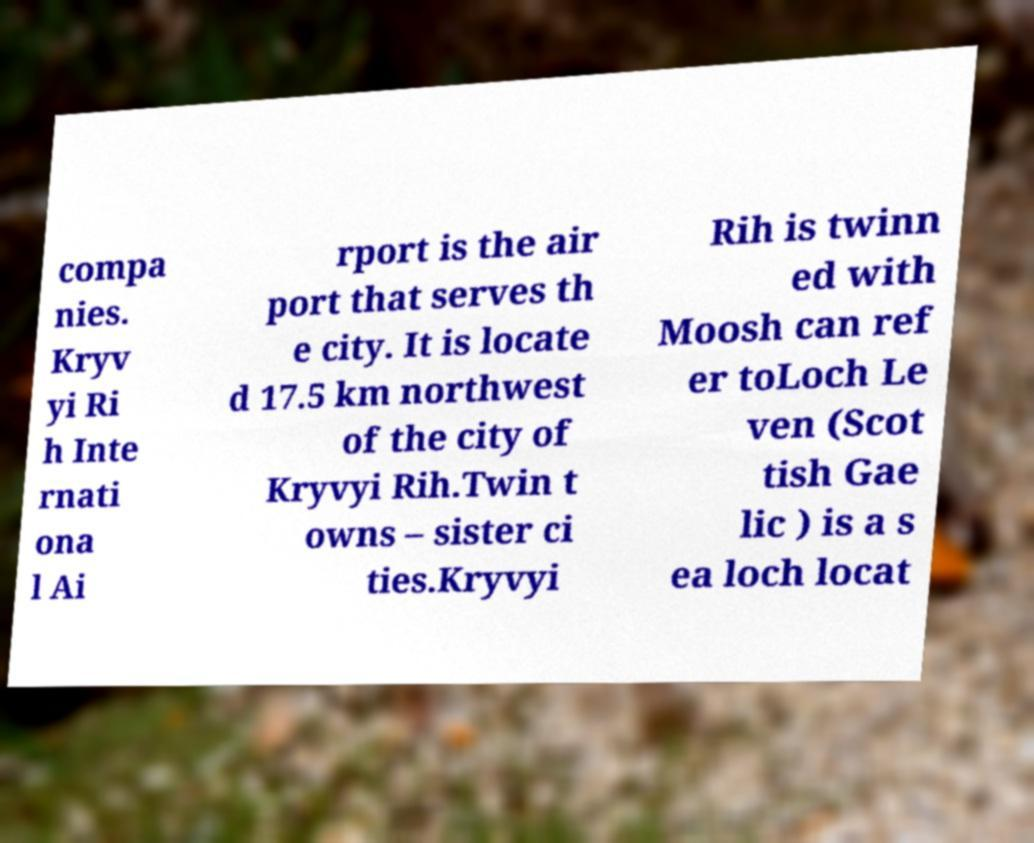For documentation purposes, I need the text within this image transcribed. Could you provide that? compa nies. Kryv yi Ri h Inte rnati ona l Ai rport is the air port that serves th e city. It is locate d 17.5 km northwest of the city of Kryvyi Rih.Twin t owns – sister ci ties.Kryvyi Rih is twinn ed with Moosh can ref er toLoch Le ven (Scot tish Gae lic ) is a s ea loch locat 